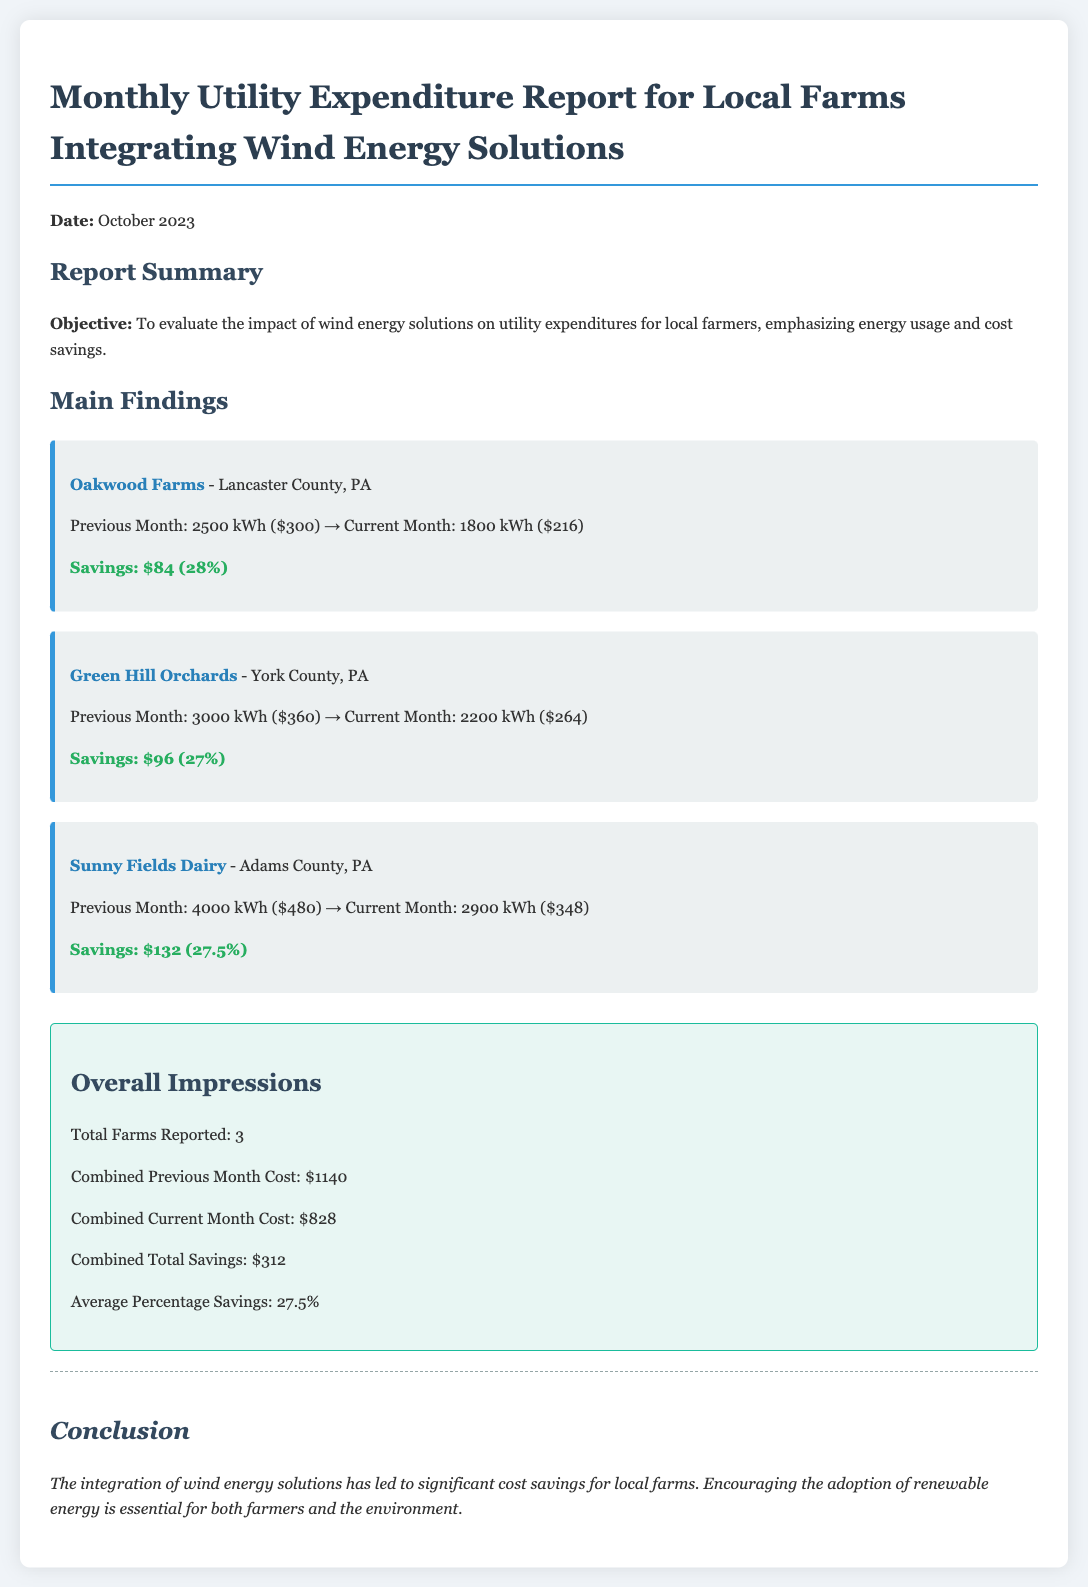what is the date of the report? The date of the report is mentioned at the beginning of the document as October 2023.
Answer: October 2023 who is the farm with the highest savings? The farm with the highest savings is determined by comparing the savings percentages, which shows Sunny Fields Dairy has $132 in savings.
Answer: Sunny Fields Dairy what is the average percentage savings across the farms? The average percentage savings is calculated from the combined savings, which equals 27.5%.
Answer: 27.5% what was the total previous month cost for all farms? The total previous month cost is stated in the overall section as $1140, representing the sum of costs for all farms.
Answer: $1140 how much energy did Oakwood Farms use in the current month? The current month energy usage for Oakwood Farms is specified as 1800 kWh, indicating the amount consumed.
Answer: 1800 kWh what is the report's objective? The report's objective is to evaluate the impact of wind energy solutions on utility expenditures for local farmers.
Answer: To evaluate the impact of wind energy solutions on utility expenditures how many farms reported their data? The overall impressions section states that a total of 3 farms reported their data in this document.
Answer: 3 what was the combined current month cost for all farms? The combined current month cost is shown in the overall impressions section as $828.
Answer: $828 what is the percentage savings for Green Hill Orchards? The percentage savings for Green Hill Orchards is noted as 27%, reflecting the reduction in utility expenditures.
Answer: 27% 